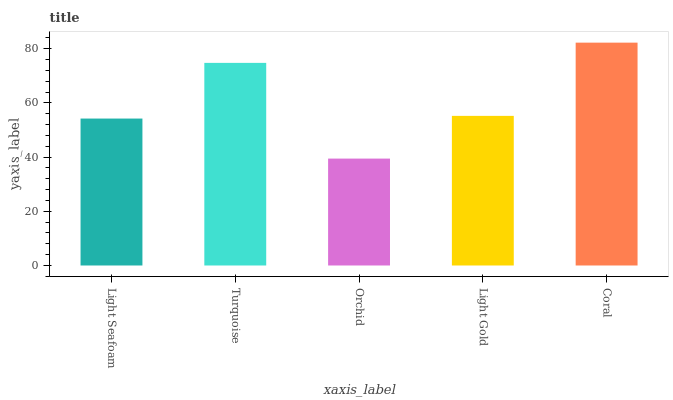Is Orchid the minimum?
Answer yes or no. Yes. Is Coral the maximum?
Answer yes or no. Yes. Is Turquoise the minimum?
Answer yes or no. No. Is Turquoise the maximum?
Answer yes or no. No. Is Turquoise greater than Light Seafoam?
Answer yes or no. Yes. Is Light Seafoam less than Turquoise?
Answer yes or no. Yes. Is Light Seafoam greater than Turquoise?
Answer yes or no. No. Is Turquoise less than Light Seafoam?
Answer yes or no. No. Is Light Gold the high median?
Answer yes or no. Yes. Is Light Gold the low median?
Answer yes or no. Yes. Is Coral the high median?
Answer yes or no. No. Is Light Seafoam the low median?
Answer yes or no. No. 